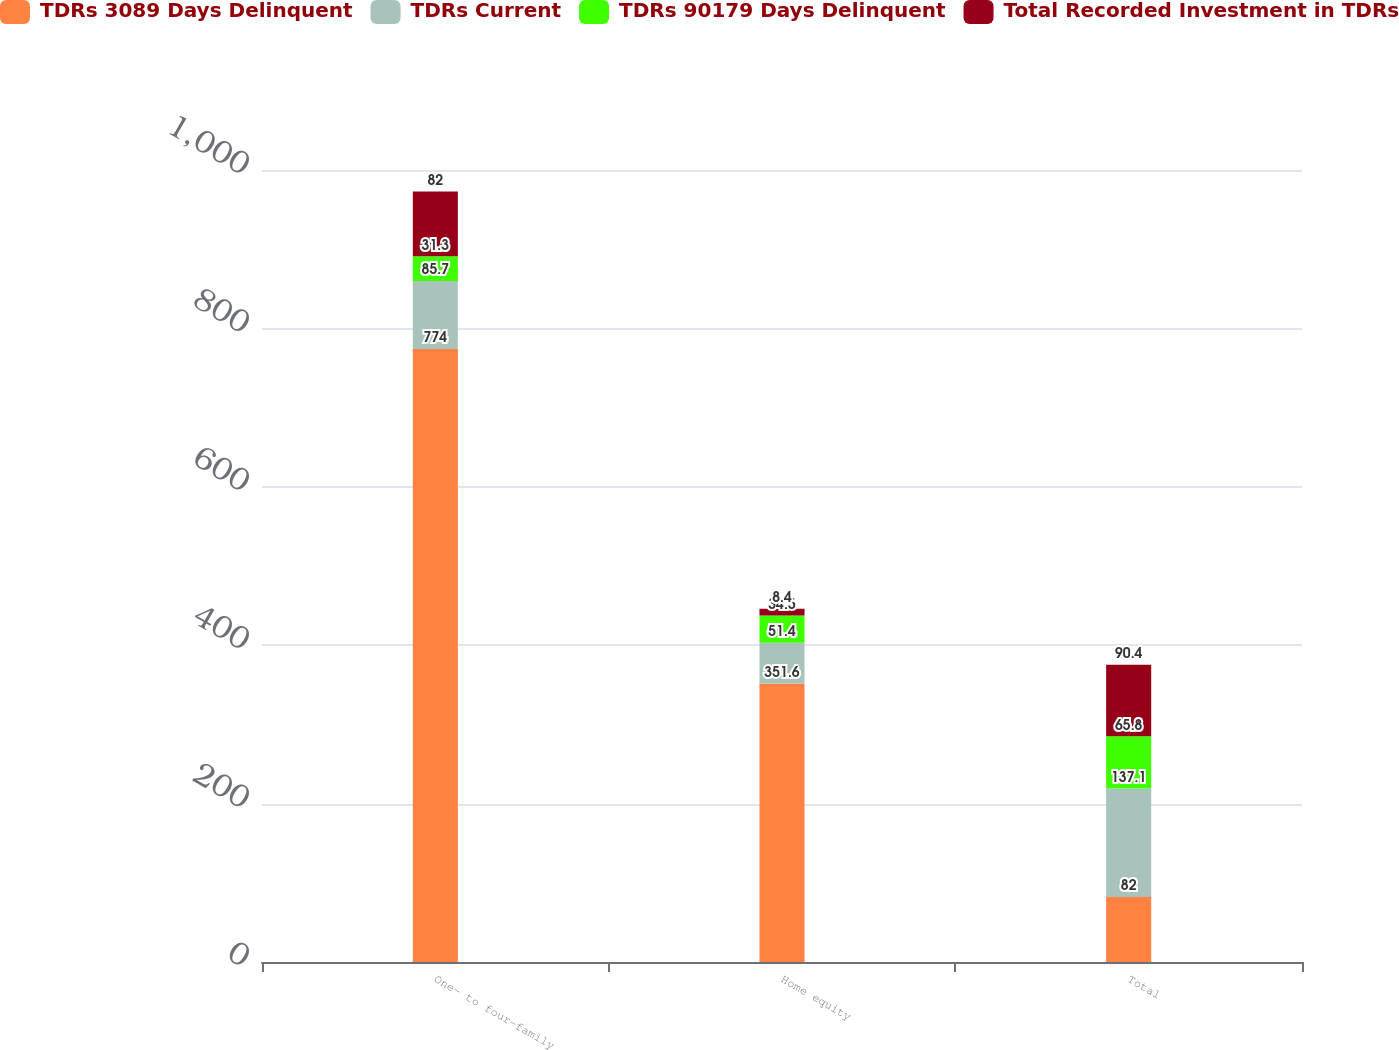<chart> <loc_0><loc_0><loc_500><loc_500><stacked_bar_chart><ecel><fcel>One- to four-family<fcel>Home equity<fcel>Total<nl><fcel>TDRs 3089 Days Delinquent<fcel>774<fcel>351.6<fcel>82<nl><fcel>TDRs Current<fcel>85.7<fcel>51.4<fcel>137.1<nl><fcel>TDRs 90179 Days Delinquent<fcel>31.3<fcel>34.5<fcel>65.8<nl><fcel>Total Recorded Investment in TDRs<fcel>82<fcel>8.4<fcel>90.4<nl></chart> 